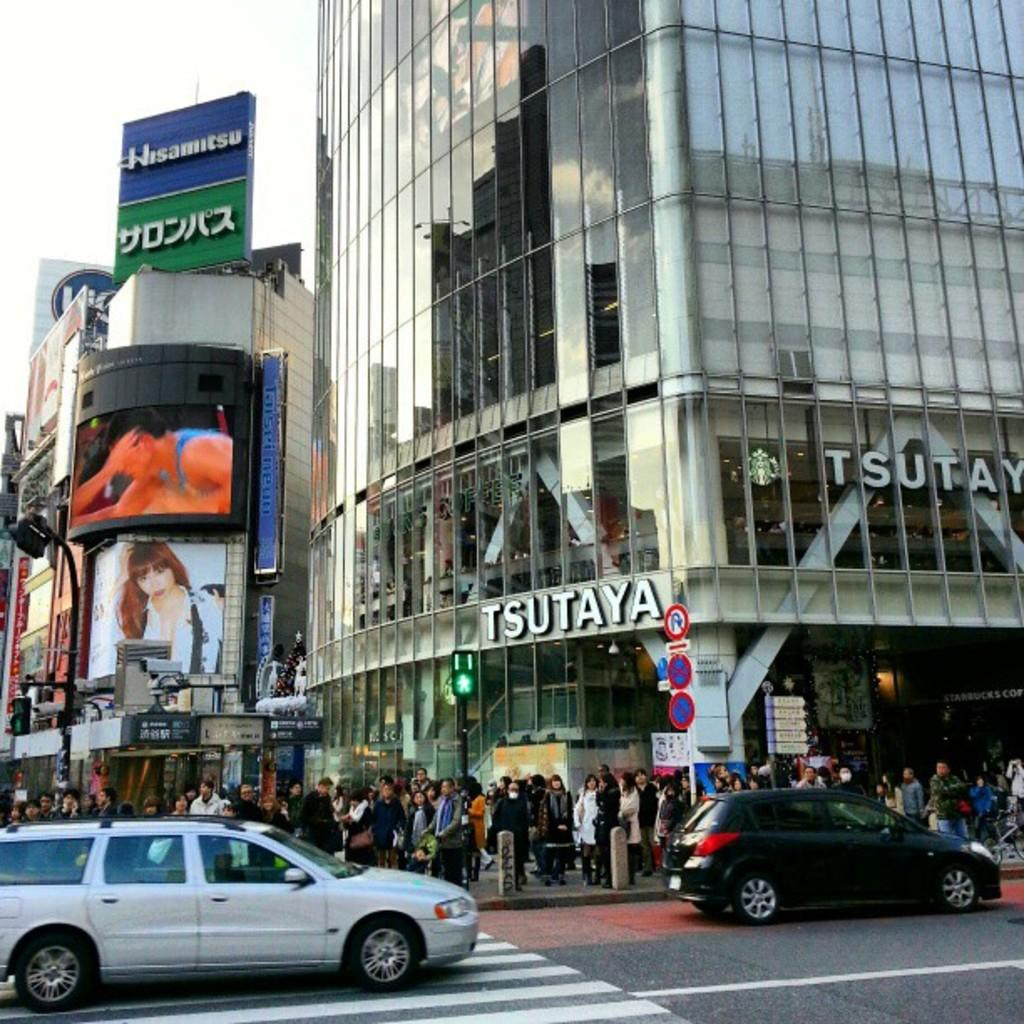What type of structures can be seen in the image? There are buildings with windows in the image. What object is present in the image that might be used for displaying information or announcements? There is a board in the image. Can you describe the people in the image? There are people standing in the image. What mode of transportation can be seen on the road in the image? There are cars on the road in the image. What part of the natural environment is visible in the image? The sky is visible in the image. What type of account is being discussed by the giants in the image? There are no giants present in the image, so no account is being discussed. What type of collar is visible on the people in the image? There is no collar visible on the people in the image. 